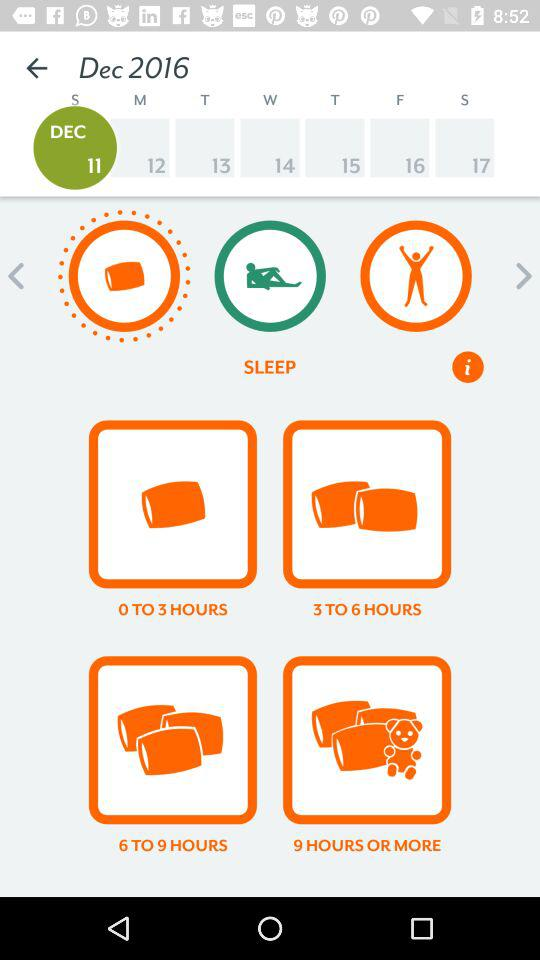How many sleep cycle are there?
When the provided information is insufficient, respond with <no answer>. <no answer> 